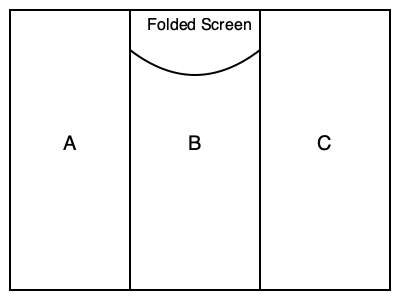A folding medical privacy screen consists of three equal-sized panels (A, B, and C) as shown in the diagram. If each panel is 4 feet wide, and the screen is partially folded so that panel B forms a 60-degree angle with panel A, what is the total width of the folded screen to the nearest foot? To solve this problem, let's follow these steps:

1. Understand the given information:
   - The screen has three equal panels, each 4 feet wide.
   - Panel B forms a 60-degree angle with panel A.

2. Visualize the folded screen:
   - Panels A and C will be parallel to each other.
   - Panel B will be at a 60-degree angle to both A and C.

3. Calculate the width contribution of panels A and C:
   - This is simply the width of one panel: 4 feet.

4. Calculate the width contribution of panel B:
   - We need to find the horizontal component of panel B's width.
   - This forms a right triangle where:
     - The hypotenuse is 4 feet (panel width).
     - The angle between the hypotenuse and the horizontal is 30 degrees (90° - 60° = 30°).

5. Use trigonometry to find the horizontal component:
   - $\cos(30°) = \text{adjacent} / \text{hypotenuse}$
   - $\text{adjacent} = 4 \times \cos(30°)$
   - $\text{adjacent} = 4 \times \frac{\sqrt{3}}{2} \approx 3.46$ feet

6. Sum up the total width:
   - Total width = Width of A + Horizontal component of B + Width of C
   - $\text{Total width} = 4 + 3.46 + 4 = 11.46$ feet

7. Round to the nearest foot:
   - 11.46 feet rounds to 11 feet.
Answer: 11 feet 